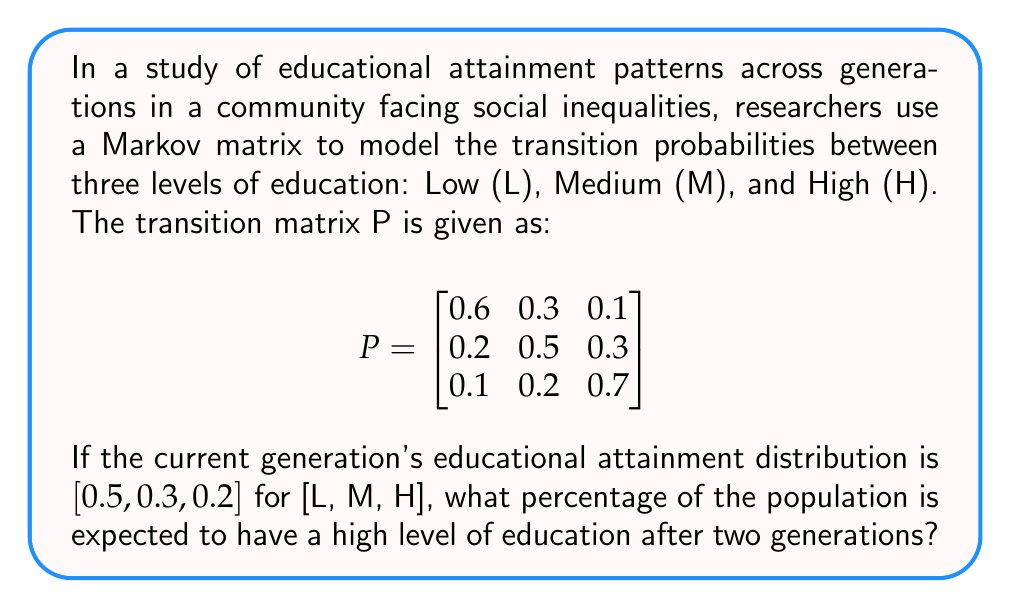Provide a solution to this math problem. Let's approach this step-by-step:

1) The initial distribution vector is $v_0 = [0.5, 0.3, 0.2]$.

2) To find the distribution after two generations, we need to multiply $v_0$ by $P$ twice:
   $v_2 = v_0 \cdot P^2$

3) First, let's calculate $P^2$:
   $$P^2 = P \cdot P = \begin{bmatrix}
   0.6 & 0.3 & 0.1 \\
   0.2 & 0.5 & 0.3 \\
   0.1 & 0.2 & 0.7
   \end{bmatrix} \cdot \begin{bmatrix}
   0.6 & 0.3 & 0.1 \\
   0.2 & 0.5 & 0.3 \\
   0.1 & 0.2 & 0.7
   \end{bmatrix}$$

4) Multiplying these matrices:
   $$P^2 = \begin{bmatrix}
   0.43 & 0.35 & 0.22 \\
   0.29 & 0.40 & 0.31 \\
   0.19 & 0.28 & 0.53
   \end{bmatrix}$$

5) Now, we multiply $v_0$ by $P^2$:
   $v_2 = [0.5, 0.3, 0.2] \cdot \begin{bmatrix}
   0.43 & 0.35 & 0.22 \\
   0.29 & 0.40 & 0.31 \\
   0.19 & 0.28 & 0.53
   \end{bmatrix}$

6) Performing this multiplication:
   $v_2 = [0.3550, 0.3550, 0.2900]$

7) The last element of $v_2$ represents the proportion of the population with high education after two generations.

8) Converting to a percentage: $0.2900 \times 100\% = 29\%$
Answer: 29% 